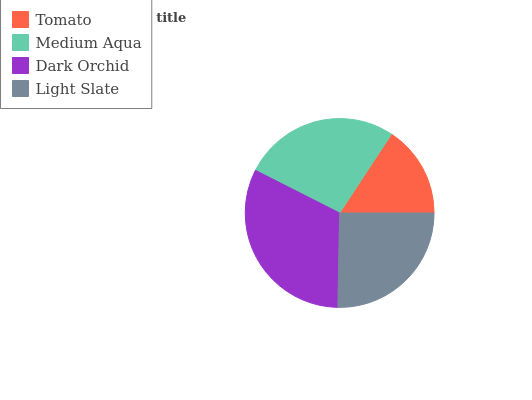Is Tomato the minimum?
Answer yes or no. Yes. Is Dark Orchid the maximum?
Answer yes or no. Yes. Is Medium Aqua the minimum?
Answer yes or no. No. Is Medium Aqua the maximum?
Answer yes or no. No. Is Medium Aqua greater than Tomato?
Answer yes or no. Yes. Is Tomato less than Medium Aqua?
Answer yes or no. Yes. Is Tomato greater than Medium Aqua?
Answer yes or no. No. Is Medium Aqua less than Tomato?
Answer yes or no. No. Is Medium Aqua the high median?
Answer yes or no. Yes. Is Light Slate the low median?
Answer yes or no. Yes. Is Tomato the high median?
Answer yes or no. No. Is Dark Orchid the low median?
Answer yes or no. No. 